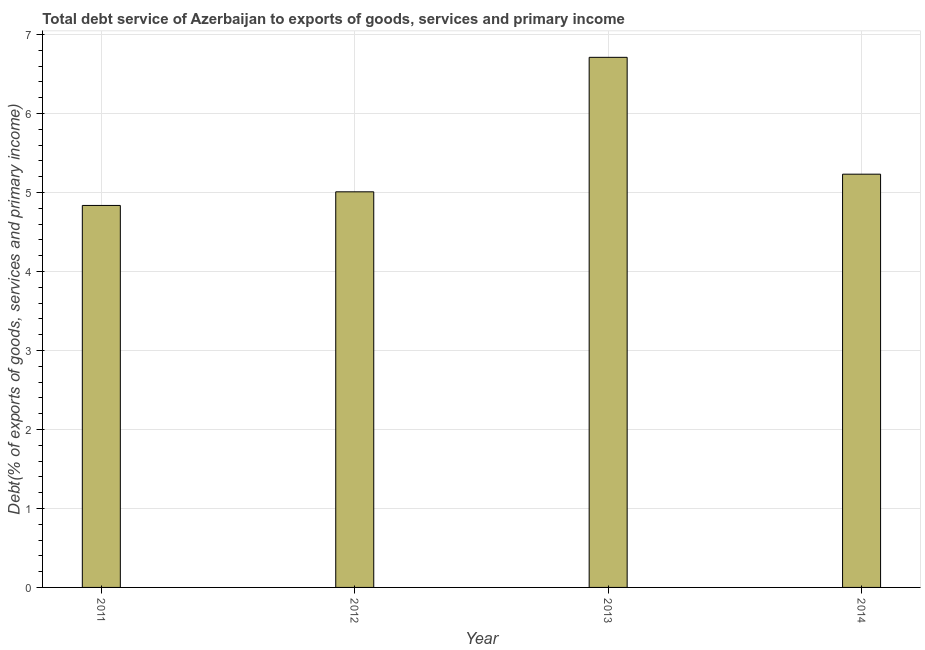Does the graph contain any zero values?
Offer a terse response. No. What is the title of the graph?
Provide a succinct answer. Total debt service of Azerbaijan to exports of goods, services and primary income. What is the label or title of the Y-axis?
Provide a short and direct response. Debt(% of exports of goods, services and primary income). What is the total debt service in 2011?
Make the answer very short. 4.84. Across all years, what is the maximum total debt service?
Provide a short and direct response. 6.71. Across all years, what is the minimum total debt service?
Keep it short and to the point. 4.84. In which year was the total debt service minimum?
Provide a succinct answer. 2011. What is the sum of the total debt service?
Your answer should be very brief. 21.79. What is the difference between the total debt service in 2011 and 2013?
Your answer should be compact. -1.88. What is the average total debt service per year?
Your answer should be compact. 5.45. What is the median total debt service?
Offer a terse response. 5.12. Do a majority of the years between 2011 and 2013 (inclusive) have total debt service greater than 1.6 %?
Offer a very short reply. Yes. What is the ratio of the total debt service in 2012 to that in 2014?
Offer a very short reply. 0.96. What is the difference between the highest and the second highest total debt service?
Your answer should be compact. 1.48. Is the sum of the total debt service in 2011 and 2012 greater than the maximum total debt service across all years?
Make the answer very short. Yes. What is the difference between the highest and the lowest total debt service?
Keep it short and to the point. 1.88. In how many years, is the total debt service greater than the average total debt service taken over all years?
Your response must be concise. 1. How many bars are there?
Provide a succinct answer. 4. Are all the bars in the graph horizontal?
Your answer should be very brief. No. How many years are there in the graph?
Make the answer very short. 4. What is the Debt(% of exports of goods, services and primary income) of 2011?
Your answer should be compact. 4.84. What is the Debt(% of exports of goods, services and primary income) of 2012?
Provide a succinct answer. 5.01. What is the Debt(% of exports of goods, services and primary income) in 2013?
Provide a succinct answer. 6.71. What is the Debt(% of exports of goods, services and primary income) of 2014?
Provide a short and direct response. 5.23. What is the difference between the Debt(% of exports of goods, services and primary income) in 2011 and 2012?
Ensure brevity in your answer.  -0.17. What is the difference between the Debt(% of exports of goods, services and primary income) in 2011 and 2013?
Provide a succinct answer. -1.88. What is the difference between the Debt(% of exports of goods, services and primary income) in 2011 and 2014?
Your response must be concise. -0.4. What is the difference between the Debt(% of exports of goods, services and primary income) in 2012 and 2013?
Keep it short and to the point. -1.7. What is the difference between the Debt(% of exports of goods, services and primary income) in 2012 and 2014?
Your answer should be compact. -0.22. What is the difference between the Debt(% of exports of goods, services and primary income) in 2013 and 2014?
Make the answer very short. 1.48. What is the ratio of the Debt(% of exports of goods, services and primary income) in 2011 to that in 2013?
Offer a terse response. 0.72. What is the ratio of the Debt(% of exports of goods, services and primary income) in 2011 to that in 2014?
Ensure brevity in your answer.  0.92. What is the ratio of the Debt(% of exports of goods, services and primary income) in 2012 to that in 2013?
Your response must be concise. 0.75. What is the ratio of the Debt(% of exports of goods, services and primary income) in 2013 to that in 2014?
Provide a succinct answer. 1.28. 